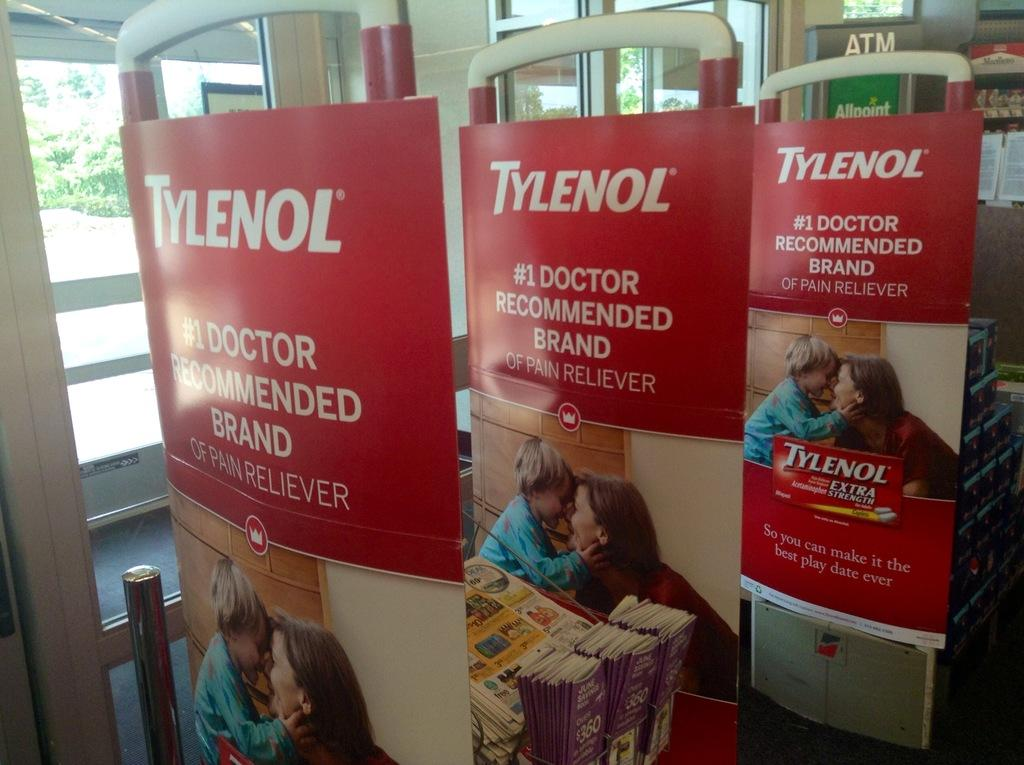<image>
Write a terse but informative summary of the picture. A advertisement for Tylenol claims it is the #1 doctor recommended brand of pain reliever. 